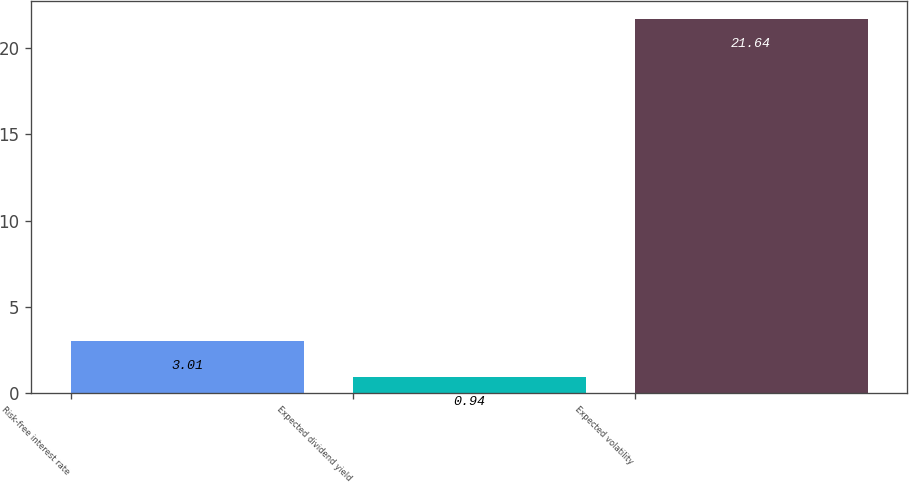Convert chart to OTSL. <chart><loc_0><loc_0><loc_500><loc_500><bar_chart><fcel>Risk-free interest rate<fcel>Expected dividend yield<fcel>Expected volatility<nl><fcel>3.01<fcel>0.94<fcel>21.64<nl></chart> 